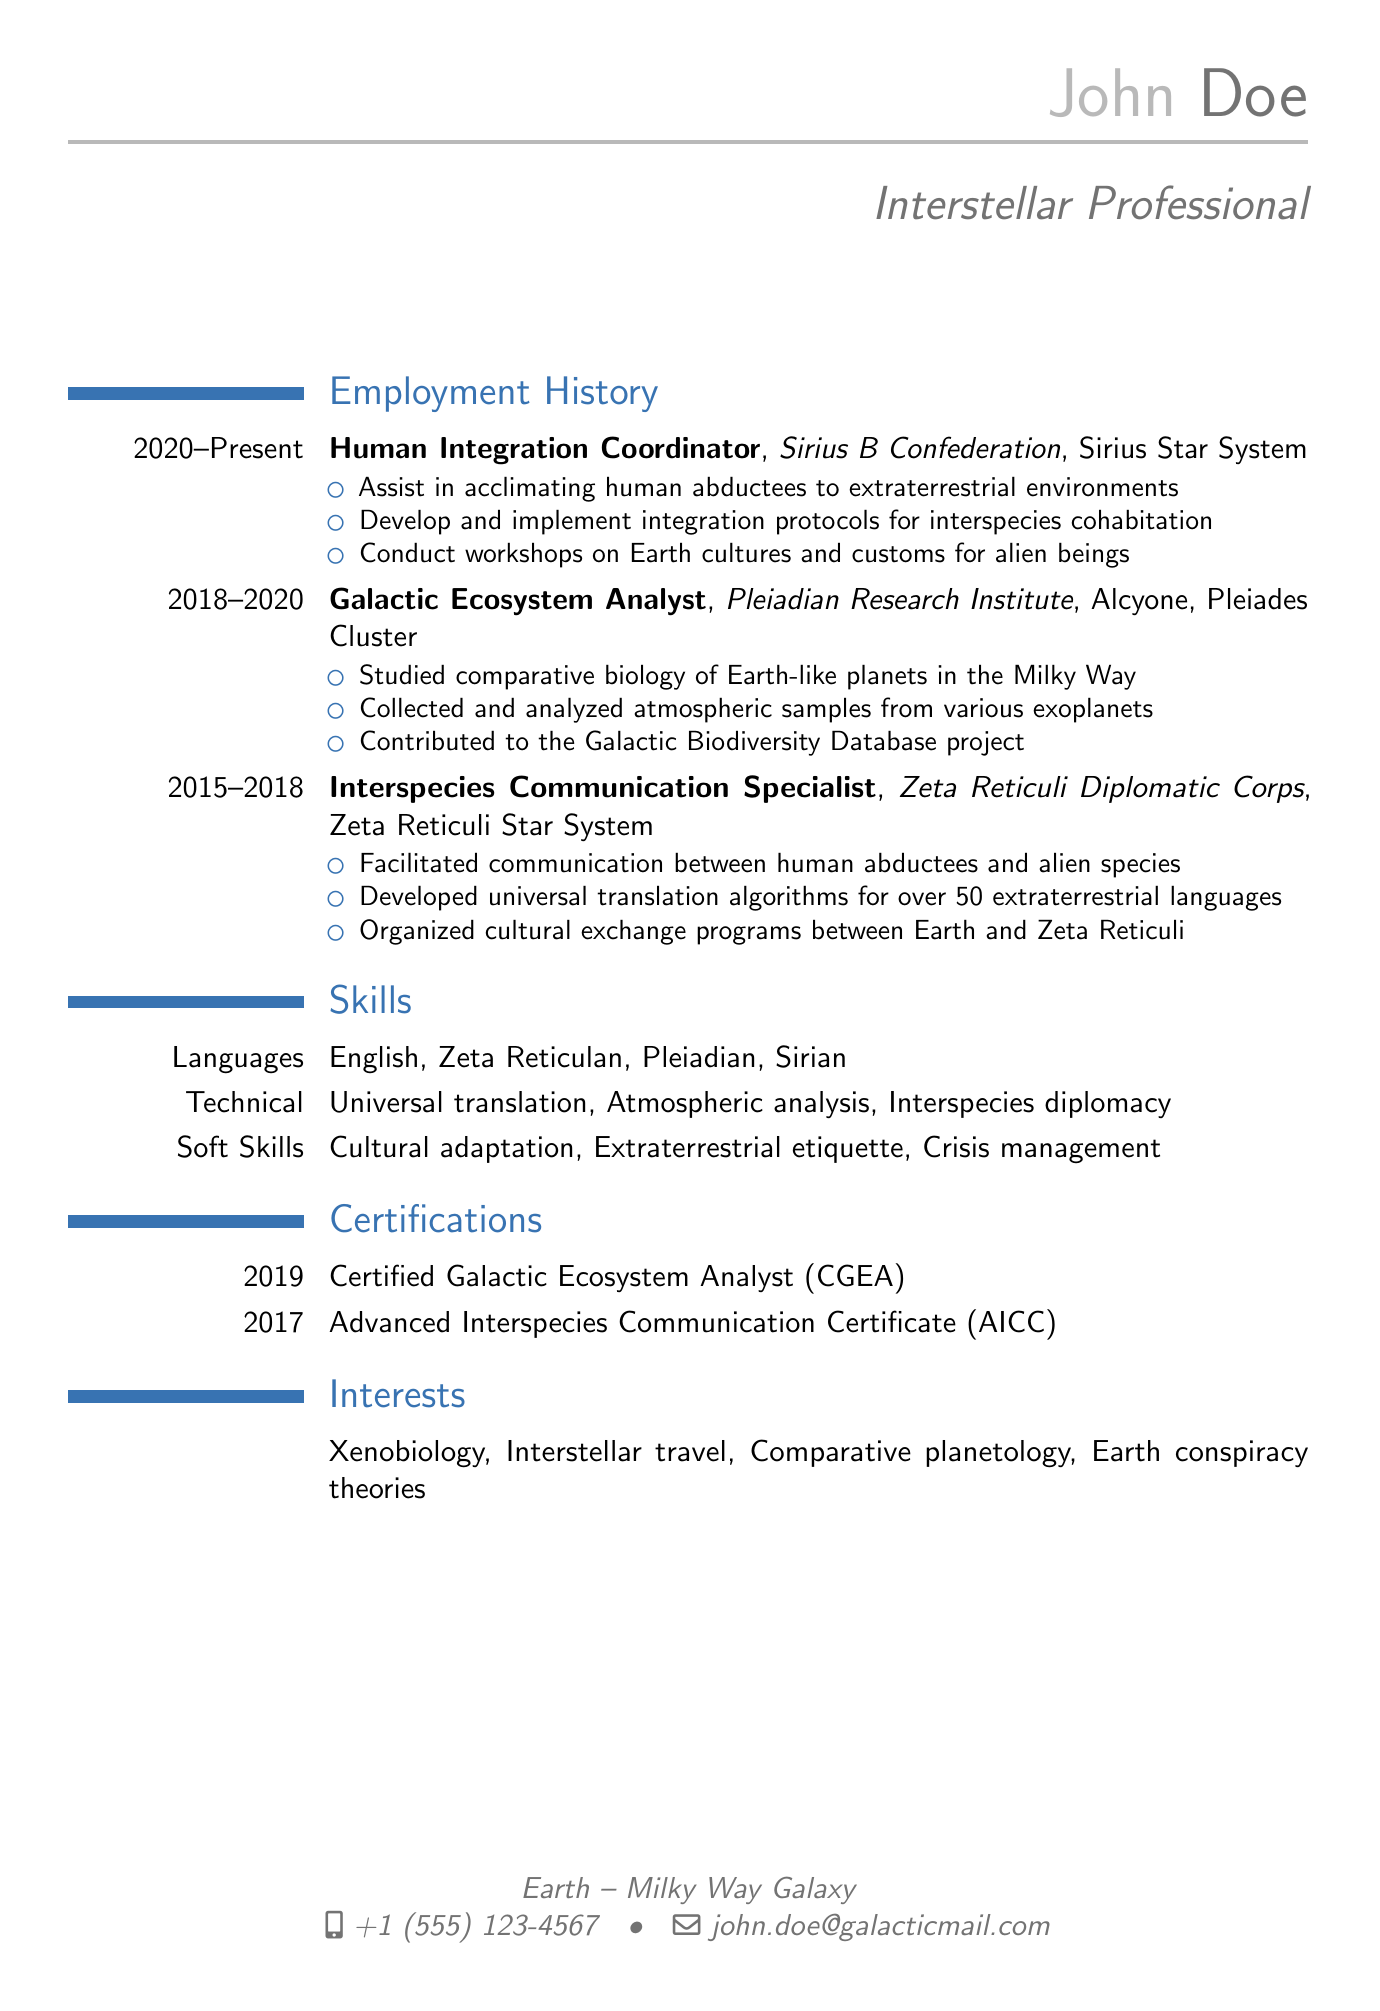What is the current position held? The current position is listed as "Human Integration Coordinator."
Answer: Human Integration Coordinator Which employer did you work for between 2018 and 2020? The employer for that duration was the "Pleiadian Research Institute."
Answer: Pleiadian Research Institute How long did you work as an Interspecies Communication Specialist? The duration of this position was from 2015 to 2018, which is a total of 3 years.
Answer: 3 years In which star system is the Sirius B Confederation located? According to the document, the location is the "Sirius Star System."
Answer: Sirius Star System How many extraterrestrial languages did you develop translation algorithms for? The document states that over 50 extraterrestrial languages were involved.
Answer: 50 What is one responsibility of the Human Integration Coordinator? The resume indicates that one responsibility is to "Assist in acclimating human abductees to extraterrestrial environments."
Answer: Assist in acclimating human abductees to extraterrestrial environments What is a skill listed that is related to communication? The skills section includes "Interspecies diplomacy" as a relevant skill.
Answer: Interspecies diplomacy Which certification was obtained in 2019? The document specifies that the certification obtained in 2019 is the "Certified Galactic Ecosystem Analyst."
Answer: Certified Galactic Ecosystem Analyst What sector is the Galactic Biodiversity Database project associated with? The project pertains to "Galactic Ecosystem" as indicated in the document.
Answer: Galactic Ecosystem 